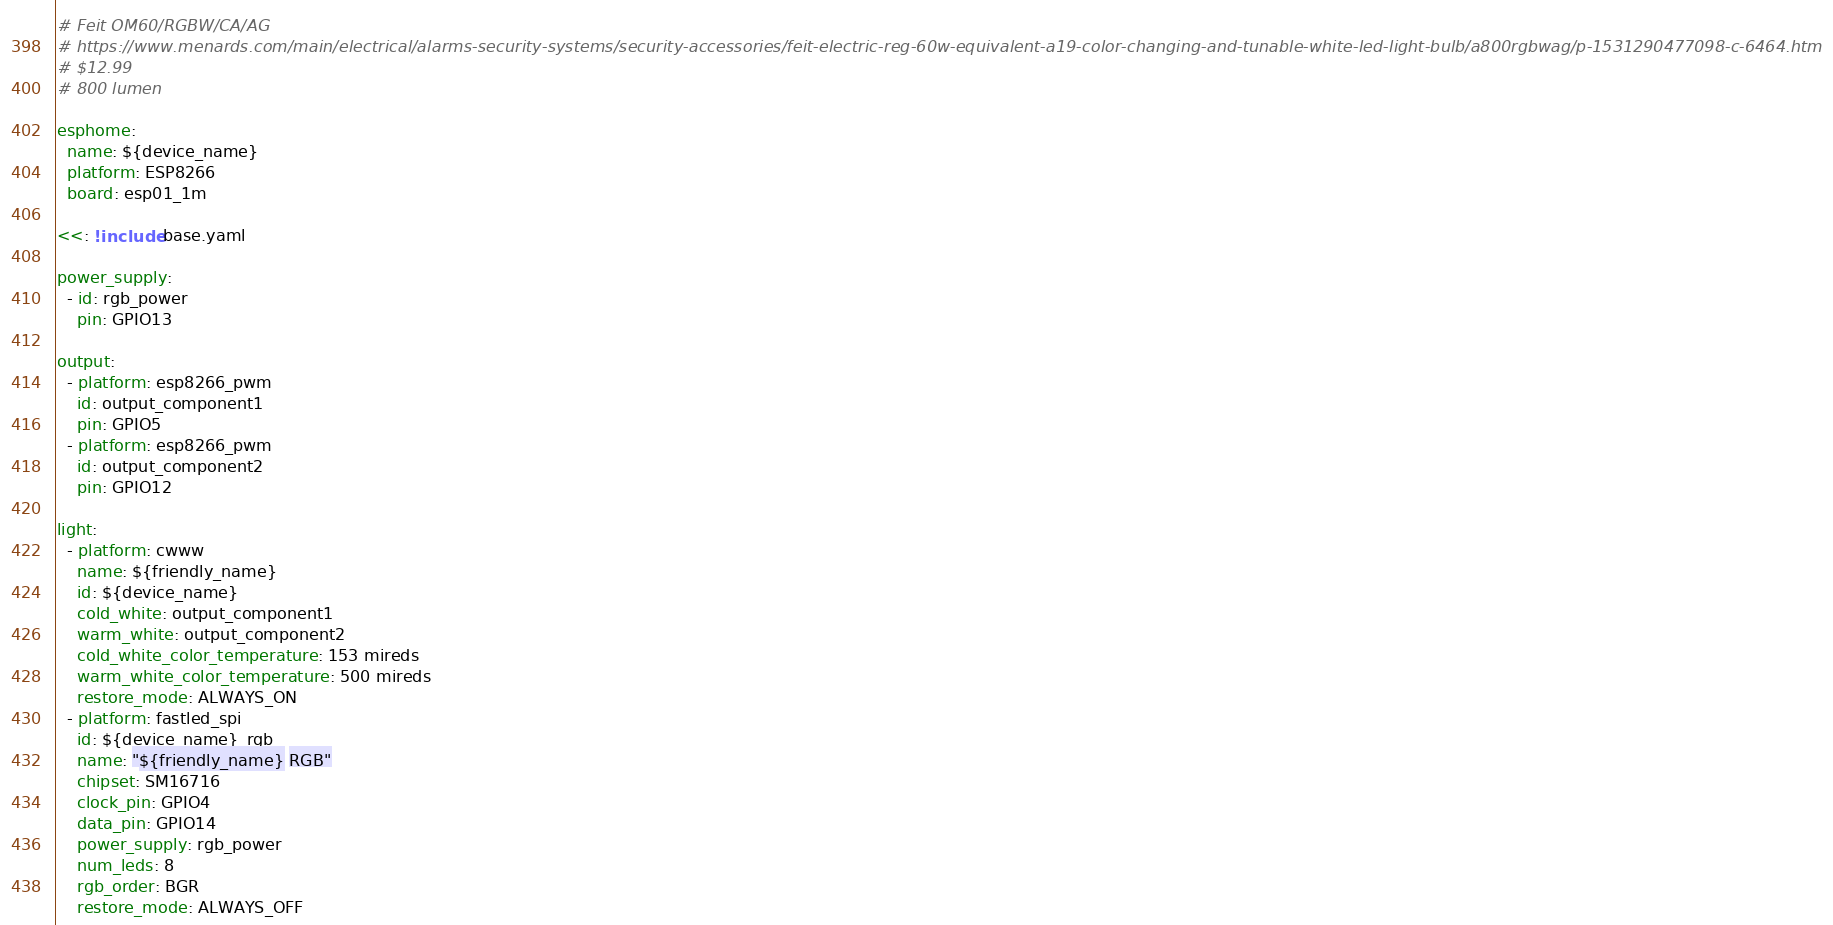Convert code to text. <code><loc_0><loc_0><loc_500><loc_500><_YAML_># Feit OM60/RGBW/CA/AG 
# https://www.menards.com/main/electrical/alarms-security-systems/security-accessories/feit-electric-reg-60w-equivalent-a19-color-changing-and-tunable-white-led-light-bulb/a800rgbwag/p-1531290477098-c-6464.htm
# $12.99 
# 800 lumen

esphome:
  name: ${device_name}
  platform: ESP8266
  board: esp01_1m
  
<<: !include base.yaml

power_supply:
  - id: rgb_power
    pin: GPIO13

output:
  - platform: esp8266_pwm
    id: output_component1
    pin: GPIO5
  - platform: esp8266_pwm
    id: output_component2
    pin: GPIO12

light:
  - platform: cwww
    name: ${friendly_name}
    id: ${device_name}
    cold_white: output_component1
    warm_white: output_component2
    cold_white_color_temperature: 153 mireds
    warm_white_color_temperature: 500 mireds
    restore_mode: ALWAYS_ON
  - platform: fastled_spi
    id: ${device_name}_rgb
    name: "${friendly_name} RGB"
    chipset: SM16716
    clock_pin: GPIO4
    data_pin: GPIO14
    power_supply: rgb_power
    num_leds: 8
    rgb_order: BGR
    restore_mode: ALWAYS_OFF

</code> 